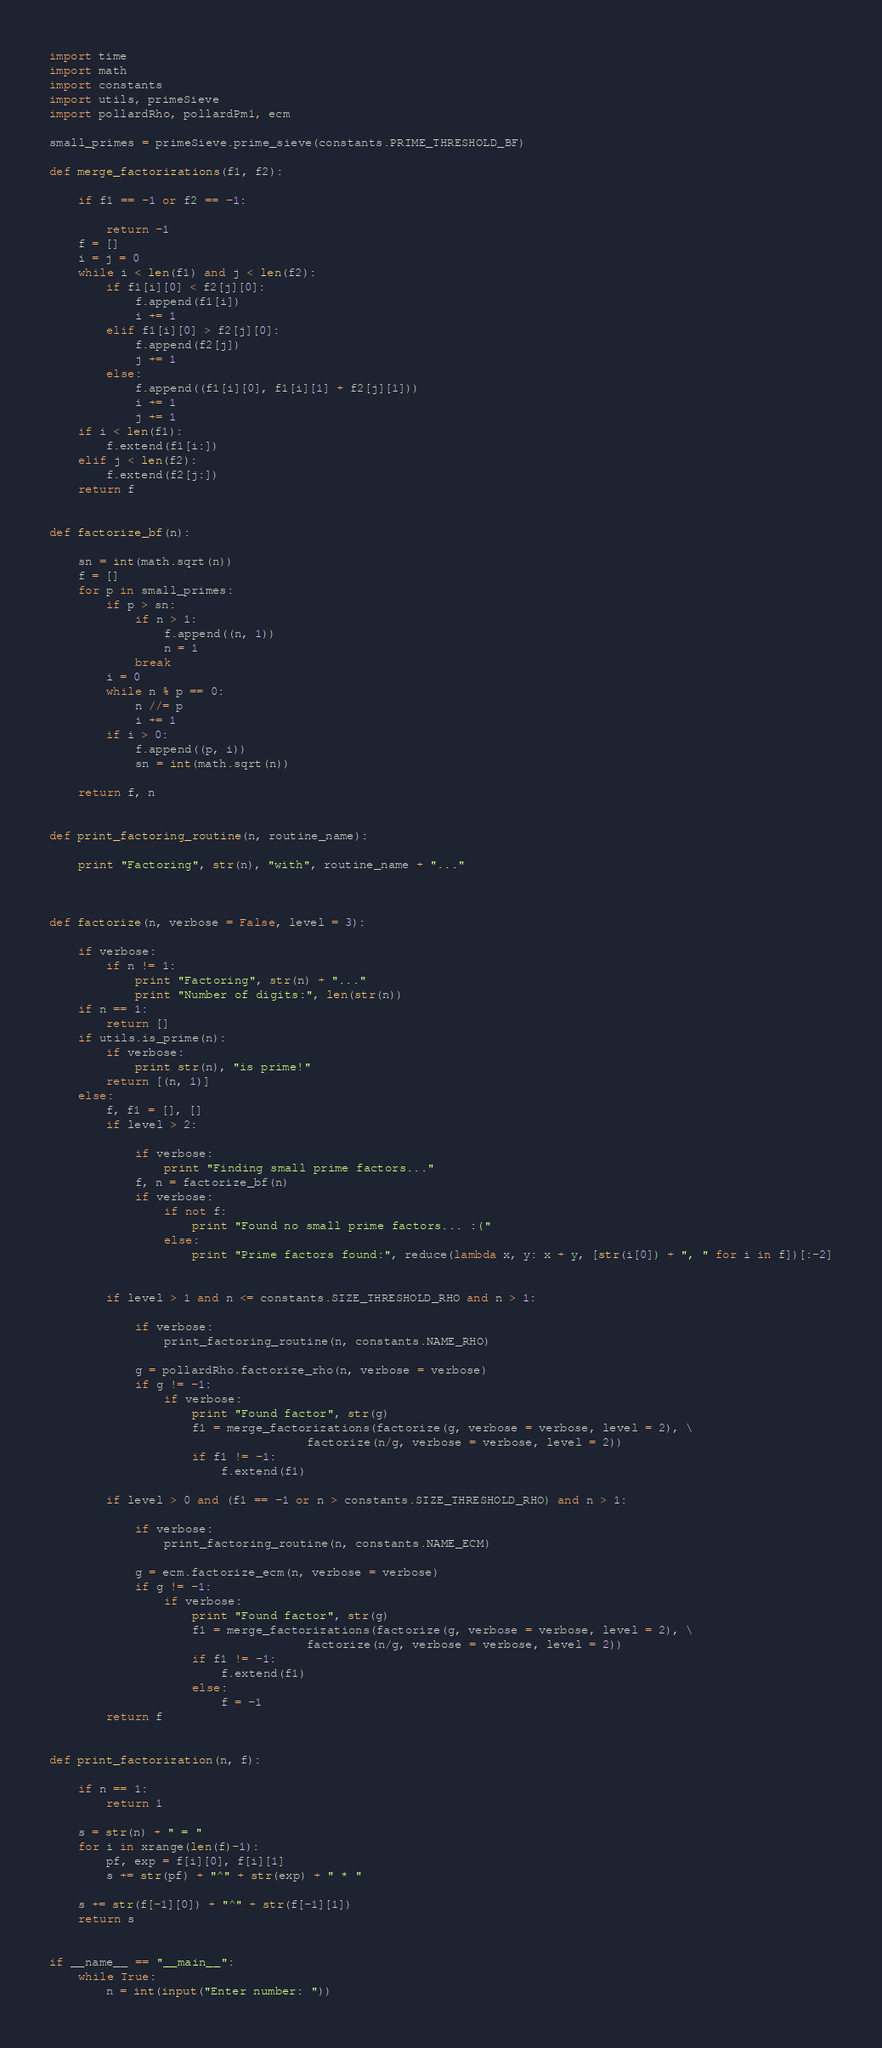Convert code to text. <code><loc_0><loc_0><loc_500><loc_500><_Python_>import time
import math
import constants
import utils, primeSieve
import pollardRho, pollardPm1, ecm

small_primes = primeSieve.prime_sieve(constants.PRIME_THRESHOLD_BF)

def merge_factorizations(f1, f2):
	
	if f1 == -1 or f2 == -1:
		
		return -1
	f = []
	i = j = 0
	while i < len(f1) and j < len(f2):
		if f1[i][0] < f2[j][0]:
			f.append(f1[i])
			i += 1
		elif f1[i][0] > f2[j][0]:
			f.append(f2[j])
			j += 1
		else:
			f.append((f1[i][0], f1[i][1] + f2[j][1]))
			i += 1
			j += 1
	if i < len(f1):
		f.extend(f1[i:])
	elif j < len(f2):
		f.extend(f2[j:])
	return f


def factorize_bf(n):
	
	sn = int(math.sqrt(n))
	f = []
	for p in small_primes:
		if p > sn:
			if n > 1:
				f.append((n, 1))
				n = 1
			break
		i = 0
		while n % p == 0:
			n //= p
			i += 1
		if i > 0:
			f.append((p, i))
 			sn = int(math.sqrt(n))
	
	return f, n


def print_factoring_routine(n, routine_name):
	
	print "Factoring", str(n), "with", routine_name + "..."



def factorize(n, verbose = False, level = 3):
	
	if verbose: 
		if n != 1: 
			print "Factoring", str(n) + "..."
			print "Number of digits:", len(str(n))
	if n == 1:
		return []
	if utils.is_prime(n):
		if verbose:
			print str(n), "is prime!"
		return [(n, 1)]
	else:
		f, f1 = [], []
		if level > 2:
			
			if verbose: 
				print "Finding small prime factors..."
			f, n = factorize_bf(n)
			if verbose:
				if not f:
					print "Found no small prime factors... :("
				else:
					print "Prime factors found:", reduce(lambda x, y: x + y, [str(i[0]) + ", " for i in f])[:-2]

		
		if level > 1 and n <= constants.SIZE_THRESHOLD_RHO and n > 1:
			
			if verbose:
				print_factoring_routine(n, constants.NAME_RHO)
			
			g = pollardRho.factorize_rho(n, verbose = verbose)
			if g != -1:
				if verbose:
					print "Found factor", str(g)
					f1 = merge_factorizations(factorize(g, verbose = verbose, level = 2), \
									factorize(n/g, verbose = verbose, level = 2))
					if f1 != -1:
						f.extend(f1)
		
		if level > 0 and (f1 == -1 or n > constants.SIZE_THRESHOLD_RHO) and n > 1:
			
			if verbose:
				print_factoring_routine(n, constants.NAME_ECM)

			g = ecm.factorize_ecm(n, verbose = verbose)
			if g != -1:
				if verbose:
					print "Found factor", str(g)
					f1 = merge_factorizations(factorize(g, verbose = verbose, level = 2), \
									factorize(n/g, verbose = verbose, level = 2))
					if f1 != -1:
						f.extend(f1)
					else:
						f = -1
		return f


def print_factorization(n, f):
	
	if n == 1:
		return 1

	s = str(n) + " = "
	for i in xrange(len(f)-1):
		pf, exp = f[i][0], f[i][1]
		s += str(pf) + "^" + str(exp) + " * "
	
	s += str(f[-1][0]) + "^" + str(f[-1][1])
	return s


if __name__ == "__main__":
	while True:
		n = int(input("Enter number: "))</code> 